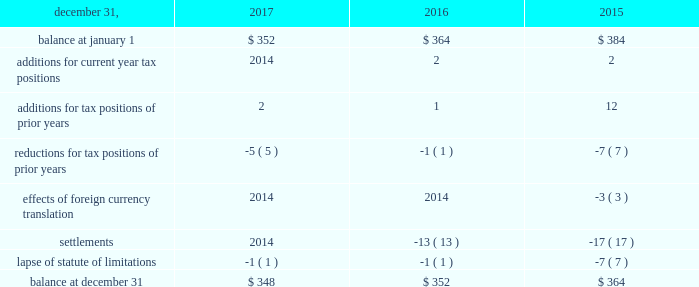The aes corporation notes to consolidated financial statements 2014 ( continued ) december 31 , 2017 , 2016 , and 2015 the total amount of unrecognized tax benefits anticipated to result in a net decrease to unrecognized tax benefits within 12 months of december 31 , 2017 is estimated to be between $ 5 million and $ 15 million , primarily relating to statute of limitation lapses and tax exam settlements .
The following is a reconciliation of the beginning and ending amounts of unrecognized tax benefits for the periods indicated ( in millions ) : .
The company and certain of its subsidiaries are currently under examination by the relevant taxing authorities for various tax years .
The company regularly assesses the potential outcome of these examinations in each of the taxing jurisdictions when determining the adequacy of the amount of unrecognized tax benefit recorded .
While it is often difficult to predict the final outcome or the timing of resolution of any particular uncertain tax position , we believe we have appropriately accrued for our uncertain tax benefits .
However , audit outcomes and the timing of audit settlements and future events that would impact our previously recorded unrecognized tax benefits and the range of anticipated increases or decreases in unrecognized tax benefits are subject to significant uncertainty .
It is possible that the ultimate outcome of current or future examinations may exceed our provision for current unrecognized tax benefits in amounts that could be material , but cannot be estimated as of december 31 , 2017 .
Our effective tax rate and net income in any given future period could therefore be materially impacted .
21 .
Discontinued operations due to a portfolio evaluation in the first half of 2016 , management decided to pursue a strategic shift of its distribution companies in brazil , sul and eletropaulo , to reduce the company's exposure to the brazilian distribution market .
Eletropaulo 2014 in november 2017 , eletropaulo converted its preferred shares into ordinary shares and transitioned the listing of those shares into the novo mercado , which is a listing segment of the brazilian stock exchange with the highest standards of corporate governance .
Upon conversion of the preferred shares into ordinary shares , aes no longer controlled eletropaulo , but maintained significant influence over the business .
As a result , the company deconsolidated eletropaulo .
After deconsolidation , the company's 17% ( 17 % ) ownership interest is reflected as an equity method investment .
The company recorded an after-tax loss on deconsolidation of $ 611 million , which primarily consisted of $ 455 million related to cumulative translation losses and $ 243 million related to pension losses reclassified from aocl .
In december 2017 , all the remaining criteria were met for eletropaulo to qualify as a discontinued operation .
Therefore , its results of operations and financial position were reported as such in the consolidated financial statements for all periods presented .
Eletropaulo's pre-tax loss attributable to aes , including the loss on deconsolidation , for the years ended december 31 , 2017 and 2016 was $ 633 million and $ 192 million , respectively .
Eletropaulo's pre-tax income attributable to aes for the year ended december 31 , 2015 was $ 73 million .
Prior to its classification as discontinued operations , eletropaulo was reported in the brazil sbu reportable segment .
Sul 2014 the company executed an agreement for the sale of sul , a wholly-owned subsidiary , in june 2016 .
The results of operations and financial position of sul are reported as discontinued operations in the consolidated financial statements for all periods presented .
Upon meeting the held-for-sale criteria , the company recognized an after-tax loss of $ 382 million comprised of a pre-tax impairment charge of $ 783 million , offset by a tax benefit of $ 266 million related to the impairment of the sul long lived assets and a tax benefit of $ 135 million for deferred taxes related to the investment in sul .
Prior to the impairment charge , the carrying value of the sul asset group of $ 1.6 billion was greater than its approximate fair value less costs to sell .
However , the impairment charge was limited to the carrying value of the long lived assets of the sul disposal group .
On october 31 , 2016 , the company completed the sale of sul and received final proceeds less costs to sell of $ 484 million , excluding contingent consideration .
Upon disposal of sul , the company incurred an additional after-tax .
What was the net change in millions in unrecognized tax benefits from 2015 to 2016? 
Computations: (352 - 364)
Answer: -12.0. 